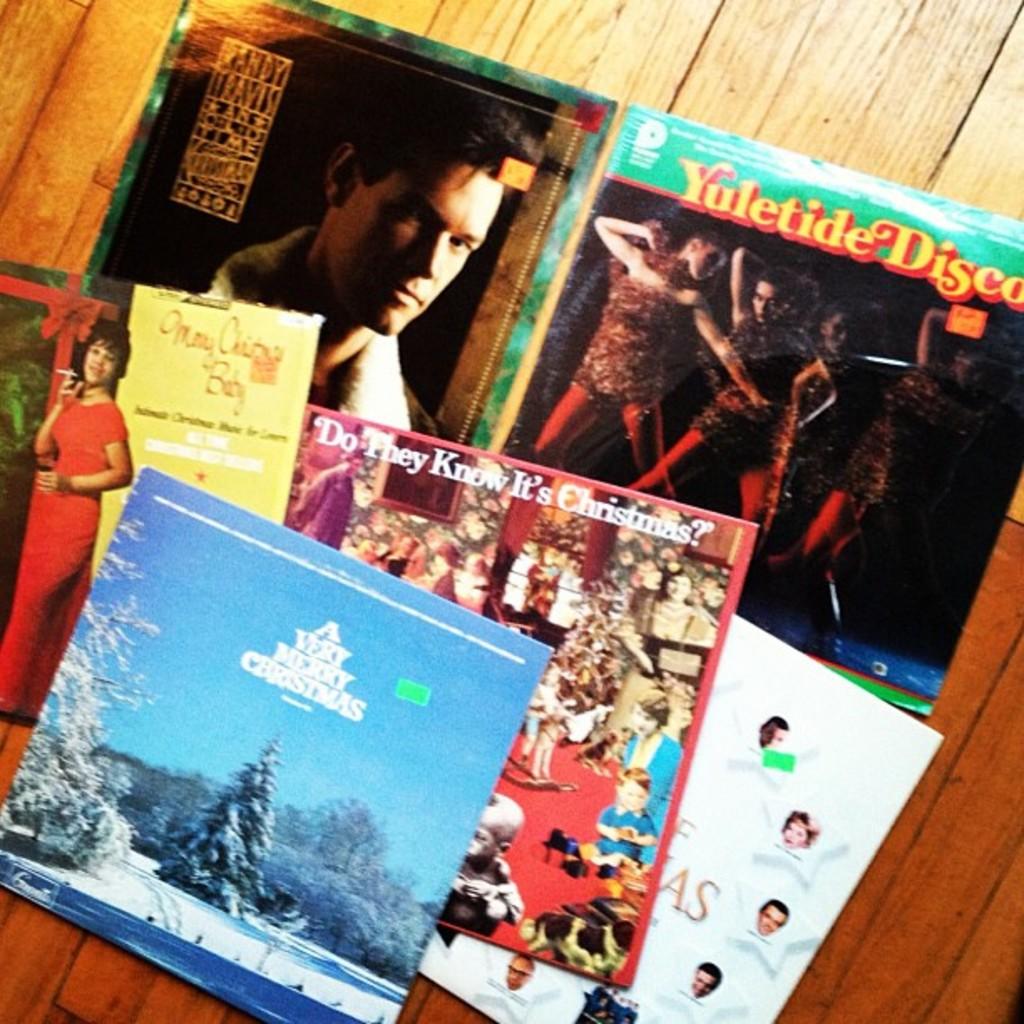The top right is titled?
Provide a short and direct response. Yuletide disco. 